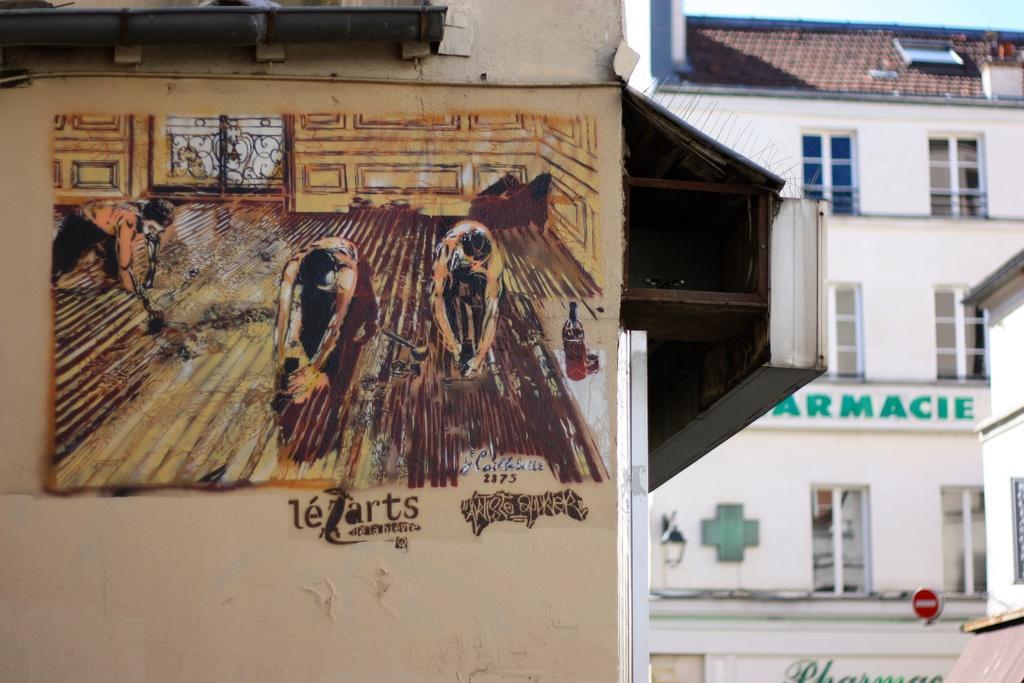Can you describe this image briefly? A painting is made on the wall of a building. There are other buildings which have windows and a sign board. 